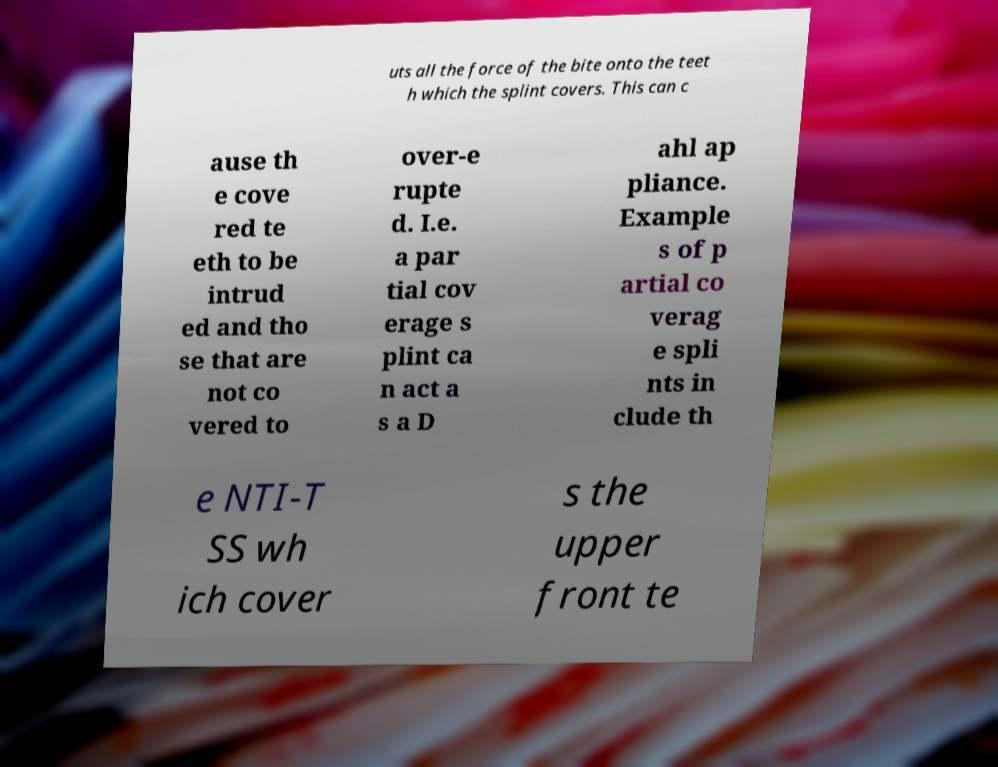What messages or text are displayed in this image? I need them in a readable, typed format. uts all the force of the bite onto the teet h which the splint covers. This can c ause th e cove red te eth to be intrud ed and tho se that are not co vered to over-e rupte d. I.e. a par tial cov erage s plint ca n act a s a D ahl ap pliance. Example s of p artial co verag e spli nts in clude th e NTI-T SS wh ich cover s the upper front te 